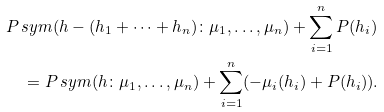Convert formula to latex. <formula><loc_0><loc_0><loc_500><loc_500>& P _ { \ } s y m ( h - ( h _ { 1 } + \dots + h _ { n } ) \colon \mu _ { 1 } , \dots , \mu _ { n } ) + \sum _ { i = 1 } ^ { n } P ( h _ { i } ) \\ & \quad = P _ { \ } s y m ( h \colon \mu _ { 1 } , \dots , \mu _ { n } ) + \sum _ { i = 1 } ^ { n } ( - \mu _ { i } ( h _ { i } ) + P ( h _ { i } ) ) .</formula> 